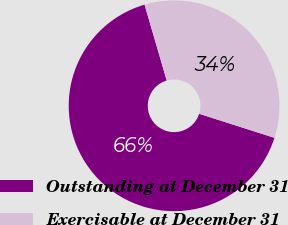Convert chart to OTSL. <chart><loc_0><loc_0><loc_500><loc_500><pie_chart><fcel>Outstanding at December 31<fcel>Exercisable at December 31<nl><fcel>65.56%<fcel>34.44%<nl></chart> 